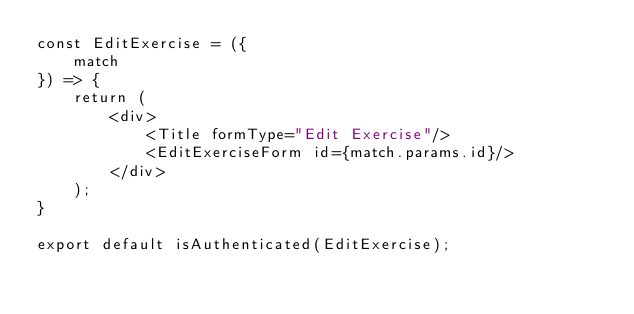Convert code to text. <code><loc_0><loc_0><loc_500><loc_500><_JavaScript_>const EditExercise = ({
    match
}) => {
    return (
        <div>
            <Title formType="Edit Exercise"/> 
            <EditExerciseForm id={match.params.id}/>
        </div>
    );
}

export default isAuthenticated(EditExercise);</code> 